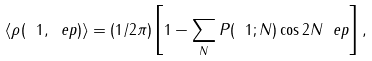Convert formula to latex. <formula><loc_0><loc_0><loc_500><loc_500>\langle \rho ( \ 1 , \ e p ) \rangle = ( 1 / 2 \pi ) \left [ 1 - \sum _ { N } P ( \ 1 ; N ) \cos { 2 N \ e p } \right ] ,</formula> 